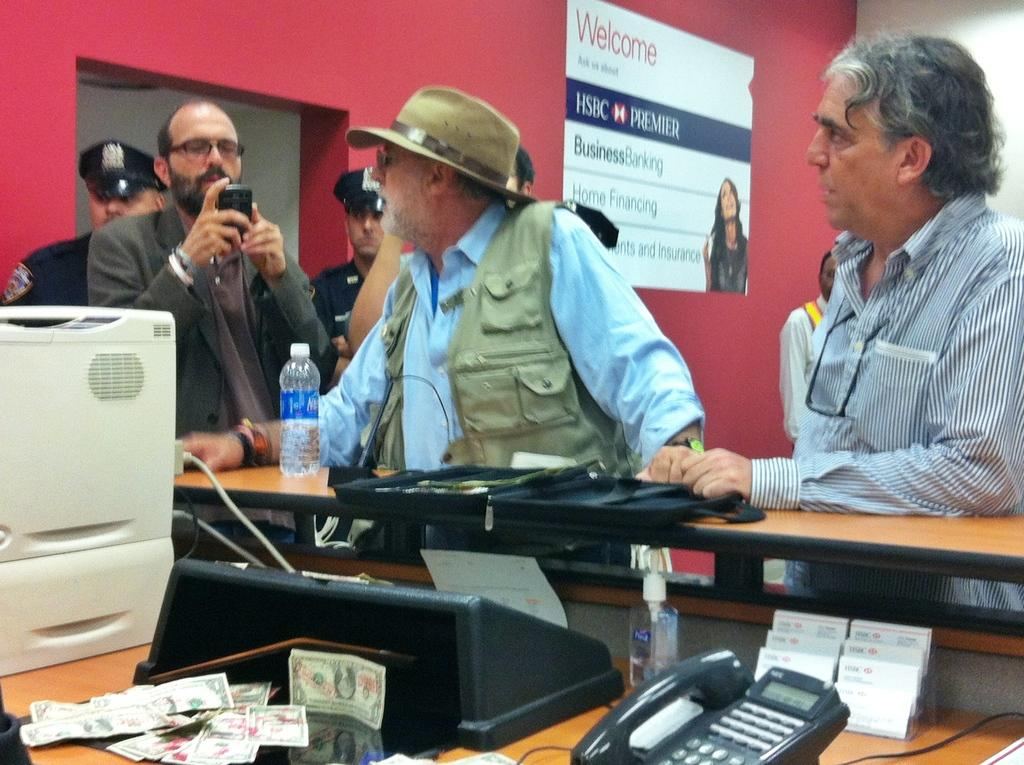How many people are in the group shown in the image? There is a group of people standing in the image, but the exact number is not specified. What type of clothing can be seen on some of the people in the image? Some people are wearing jackets and caps in the image. What items can be seen that might be used for drinking? There are bottles visible in the image. What type of eyewear can be seen on some of the people in the image? Some people are wearing spectacles in the image. What type of communication device is visible in the image? There is a mobile phone and a telephone in the image. What type of equipment is visible in the image? There are machines in the image. What type of written material is visible in the image? There are notes in the image. What type of decoration is visible on the wall in the image? There is a poster on the wall in the image. What other unspecified objects can be seen in the image? There are some unspecified objects in the image. How many dogs are present in the image? There are no dogs present in the image. What type of writing instrument is being used by the people in the image? The image does not show any writing instruments, such as quills, being used by the people. 